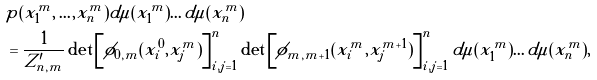<formula> <loc_0><loc_0><loc_500><loc_500>& p ( x _ { 1 } ^ { m } , \dots , x _ { n } ^ { m } ) d \mu ( x _ { 1 } ^ { m } ) \dots d \mu ( x _ { n } ^ { m } ) \\ & = \frac { 1 } { Z _ { n , m } ^ { \prime } } \det \left [ \phi _ { 0 , m } ( x _ { i } ^ { 0 } , x _ { j } ^ { m } ) \right ] _ { i , j = 1 } ^ { n } \det \left [ \phi _ { m , m + 1 } ( x _ { i } ^ { m } , x _ { j } ^ { m + 1 } ) \right ] _ { i , j = 1 } ^ { n } d \mu ( x _ { 1 } ^ { m } ) \dots d \mu ( x _ { n } ^ { m } ) ,</formula> 